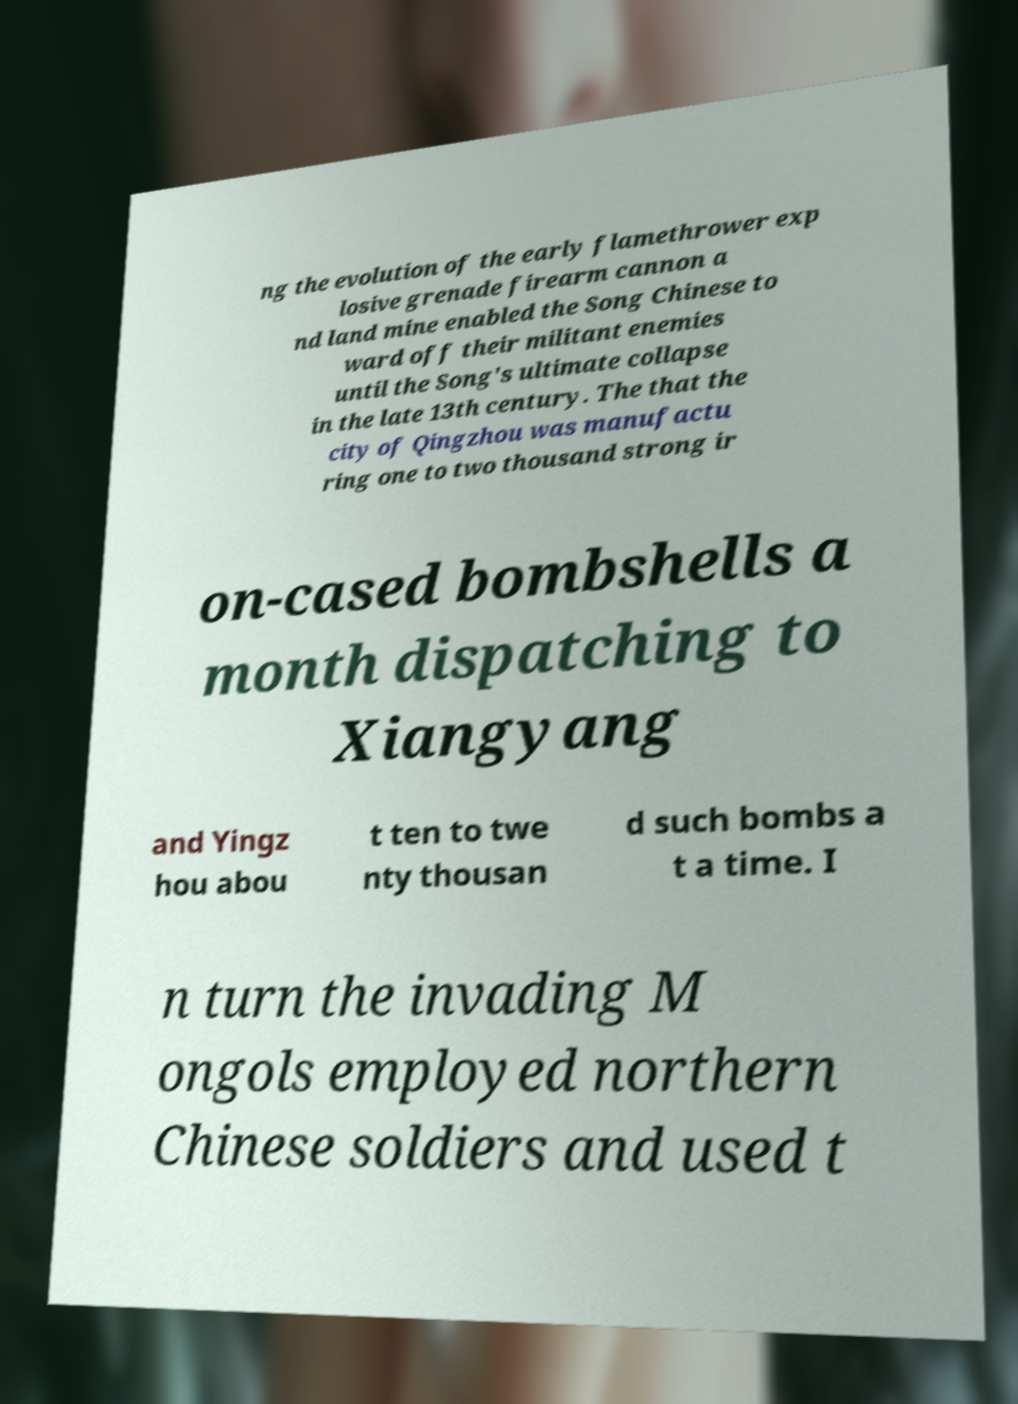I need the written content from this picture converted into text. Can you do that? ng the evolution of the early flamethrower exp losive grenade firearm cannon a nd land mine enabled the Song Chinese to ward off their militant enemies until the Song's ultimate collapse in the late 13th century. The that the city of Qingzhou was manufactu ring one to two thousand strong ir on-cased bombshells a month dispatching to Xiangyang and Yingz hou abou t ten to twe nty thousan d such bombs a t a time. I n turn the invading M ongols employed northern Chinese soldiers and used t 